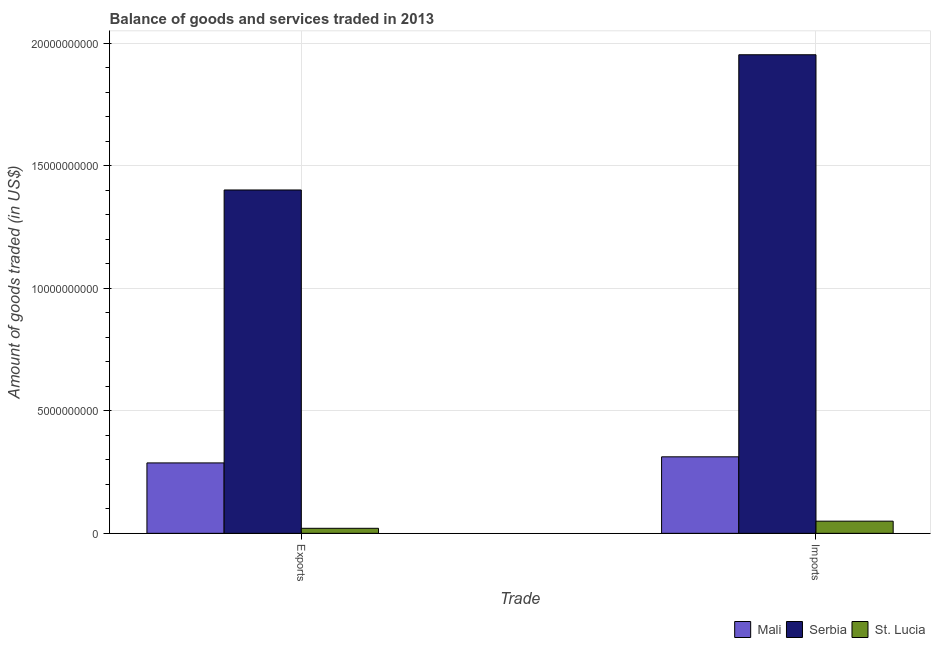How many groups of bars are there?
Your answer should be compact. 2. Are the number of bars on each tick of the X-axis equal?
Ensure brevity in your answer.  Yes. How many bars are there on the 1st tick from the left?
Give a very brief answer. 3. How many bars are there on the 1st tick from the right?
Provide a succinct answer. 3. What is the label of the 1st group of bars from the left?
Offer a terse response. Exports. What is the amount of goods imported in St. Lucia?
Offer a very short reply. 4.97e+08. Across all countries, what is the maximum amount of goods exported?
Offer a terse response. 1.40e+1. Across all countries, what is the minimum amount of goods exported?
Make the answer very short. 2.05e+08. In which country was the amount of goods exported maximum?
Ensure brevity in your answer.  Serbia. In which country was the amount of goods imported minimum?
Offer a very short reply. St. Lucia. What is the total amount of goods exported in the graph?
Provide a short and direct response. 1.71e+1. What is the difference between the amount of goods imported in Mali and that in Serbia?
Give a very brief answer. -1.64e+1. What is the difference between the amount of goods imported in St. Lucia and the amount of goods exported in Serbia?
Your answer should be very brief. -1.35e+1. What is the average amount of goods exported per country?
Make the answer very short. 5.70e+09. What is the difference between the amount of goods imported and amount of goods exported in Serbia?
Offer a very short reply. 5.52e+09. In how many countries, is the amount of goods exported greater than 3000000000 US$?
Provide a short and direct response. 1. What is the ratio of the amount of goods exported in Serbia to that in Mali?
Keep it short and to the point. 4.88. Is the amount of goods imported in Serbia less than that in Mali?
Provide a succinct answer. No. In how many countries, is the amount of goods exported greater than the average amount of goods exported taken over all countries?
Your answer should be compact. 1. What does the 2nd bar from the left in Exports represents?
Offer a terse response. Serbia. What does the 1st bar from the right in Exports represents?
Offer a very short reply. St. Lucia. How many countries are there in the graph?
Your answer should be compact. 3. What is the difference between two consecutive major ticks on the Y-axis?
Your answer should be very brief. 5.00e+09. Are the values on the major ticks of Y-axis written in scientific E-notation?
Make the answer very short. No. Does the graph contain any zero values?
Your answer should be very brief. No. How many legend labels are there?
Make the answer very short. 3. How are the legend labels stacked?
Keep it short and to the point. Horizontal. What is the title of the graph?
Make the answer very short. Balance of goods and services traded in 2013. What is the label or title of the X-axis?
Ensure brevity in your answer.  Trade. What is the label or title of the Y-axis?
Your response must be concise. Amount of goods traded (in US$). What is the Amount of goods traded (in US$) in Mali in Exports?
Ensure brevity in your answer.  2.87e+09. What is the Amount of goods traded (in US$) in Serbia in Exports?
Your response must be concise. 1.40e+1. What is the Amount of goods traded (in US$) in St. Lucia in Exports?
Your answer should be very brief. 2.05e+08. What is the Amount of goods traded (in US$) in Mali in Imports?
Provide a succinct answer. 3.12e+09. What is the Amount of goods traded (in US$) in Serbia in Imports?
Provide a succinct answer. 1.95e+1. What is the Amount of goods traded (in US$) in St. Lucia in Imports?
Give a very brief answer. 4.97e+08. Across all Trade, what is the maximum Amount of goods traded (in US$) of Mali?
Your answer should be compact. 3.12e+09. Across all Trade, what is the maximum Amount of goods traded (in US$) in Serbia?
Ensure brevity in your answer.  1.95e+1. Across all Trade, what is the maximum Amount of goods traded (in US$) in St. Lucia?
Keep it short and to the point. 4.97e+08. Across all Trade, what is the minimum Amount of goods traded (in US$) of Mali?
Offer a terse response. 2.87e+09. Across all Trade, what is the minimum Amount of goods traded (in US$) of Serbia?
Your response must be concise. 1.40e+1. Across all Trade, what is the minimum Amount of goods traded (in US$) of St. Lucia?
Provide a succinct answer. 2.05e+08. What is the total Amount of goods traded (in US$) of Mali in the graph?
Your answer should be compact. 6.00e+09. What is the total Amount of goods traded (in US$) in Serbia in the graph?
Ensure brevity in your answer.  3.35e+1. What is the total Amount of goods traded (in US$) in St. Lucia in the graph?
Offer a terse response. 7.02e+08. What is the difference between the Amount of goods traded (in US$) of Mali in Exports and that in Imports?
Keep it short and to the point. -2.49e+08. What is the difference between the Amount of goods traded (in US$) of Serbia in Exports and that in Imports?
Keep it short and to the point. -5.52e+09. What is the difference between the Amount of goods traded (in US$) in St. Lucia in Exports and that in Imports?
Ensure brevity in your answer.  -2.91e+08. What is the difference between the Amount of goods traded (in US$) of Mali in Exports and the Amount of goods traded (in US$) of Serbia in Imports?
Your response must be concise. -1.67e+1. What is the difference between the Amount of goods traded (in US$) of Mali in Exports and the Amount of goods traded (in US$) of St. Lucia in Imports?
Provide a short and direct response. 2.38e+09. What is the difference between the Amount of goods traded (in US$) in Serbia in Exports and the Amount of goods traded (in US$) in St. Lucia in Imports?
Your answer should be compact. 1.35e+1. What is the average Amount of goods traded (in US$) in Mali per Trade?
Your answer should be compact. 3.00e+09. What is the average Amount of goods traded (in US$) in Serbia per Trade?
Your answer should be very brief. 1.68e+1. What is the average Amount of goods traded (in US$) in St. Lucia per Trade?
Your answer should be compact. 3.51e+08. What is the difference between the Amount of goods traded (in US$) in Mali and Amount of goods traded (in US$) in Serbia in Exports?
Your response must be concise. -1.11e+1. What is the difference between the Amount of goods traded (in US$) of Mali and Amount of goods traded (in US$) of St. Lucia in Exports?
Your answer should be very brief. 2.67e+09. What is the difference between the Amount of goods traded (in US$) of Serbia and Amount of goods traded (in US$) of St. Lucia in Exports?
Offer a terse response. 1.38e+1. What is the difference between the Amount of goods traded (in US$) of Mali and Amount of goods traded (in US$) of Serbia in Imports?
Keep it short and to the point. -1.64e+1. What is the difference between the Amount of goods traded (in US$) of Mali and Amount of goods traded (in US$) of St. Lucia in Imports?
Make the answer very short. 2.63e+09. What is the difference between the Amount of goods traded (in US$) of Serbia and Amount of goods traded (in US$) of St. Lucia in Imports?
Make the answer very short. 1.90e+1. What is the ratio of the Amount of goods traded (in US$) in Mali in Exports to that in Imports?
Your answer should be very brief. 0.92. What is the ratio of the Amount of goods traded (in US$) of Serbia in Exports to that in Imports?
Your answer should be very brief. 0.72. What is the ratio of the Amount of goods traded (in US$) of St. Lucia in Exports to that in Imports?
Provide a short and direct response. 0.41. What is the difference between the highest and the second highest Amount of goods traded (in US$) in Mali?
Give a very brief answer. 2.49e+08. What is the difference between the highest and the second highest Amount of goods traded (in US$) of Serbia?
Offer a very short reply. 5.52e+09. What is the difference between the highest and the second highest Amount of goods traded (in US$) in St. Lucia?
Make the answer very short. 2.91e+08. What is the difference between the highest and the lowest Amount of goods traded (in US$) of Mali?
Provide a succinct answer. 2.49e+08. What is the difference between the highest and the lowest Amount of goods traded (in US$) in Serbia?
Your answer should be compact. 5.52e+09. What is the difference between the highest and the lowest Amount of goods traded (in US$) of St. Lucia?
Offer a very short reply. 2.91e+08. 